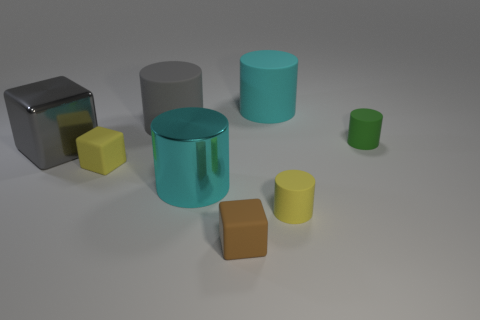How many objects are either cyan shiny cylinders or tiny cylinders that are to the right of the gray metal object?
Your response must be concise. 3. There is a yellow thing that is the same shape as the brown thing; what is it made of?
Your response must be concise. Rubber. Is the shape of the yellow matte object to the right of the big cyan shiny cylinder the same as  the cyan matte thing?
Give a very brief answer. Yes. Is the number of green objects in front of the small brown thing less than the number of objects left of the gray matte cylinder?
Ensure brevity in your answer.  Yes. What number of other objects are there of the same shape as the big cyan rubber object?
Give a very brief answer. 4. There is a matte block in front of the rubber cylinder in front of the large gray thing left of the big gray matte thing; what is its size?
Make the answer very short. Small. How many red things are either rubber cylinders or big rubber things?
Provide a short and direct response. 0. There is a big cyan object that is behind the small matte thing behind the gray metal cube; what shape is it?
Offer a terse response. Cylinder. Does the yellow thing right of the tiny brown rubber block have the same size as the matte object in front of the yellow cylinder?
Keep it short and to the point. Yes. Is there a small blue cube that has the same material as the small yellow cube?
Provide a short and direct response. No. 